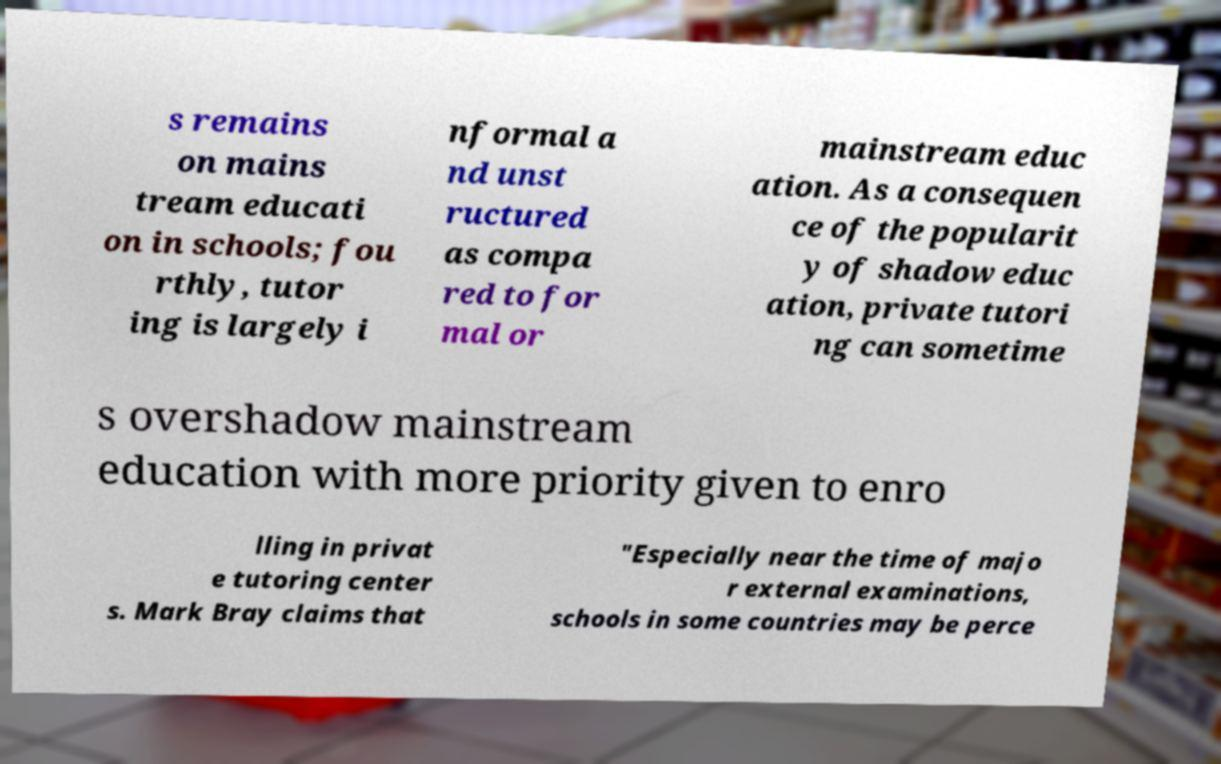Can you accurately transcribe the text from the provided image for me? s remains on mains tream educati on in schools; fou rthly, tutor ing is largely i nformal a nd unst ructured as compa red to for mal or mainstream educ ation. As a consequen ce of the popularit y of shadow educ ation, private tutori ng can sometime s overshadow mainstream education with more priority given to enro lling in privat e tutoring center s. Mark Bray claims that "Especially near the time of majo r external examinations, schools in some countries may be perce 